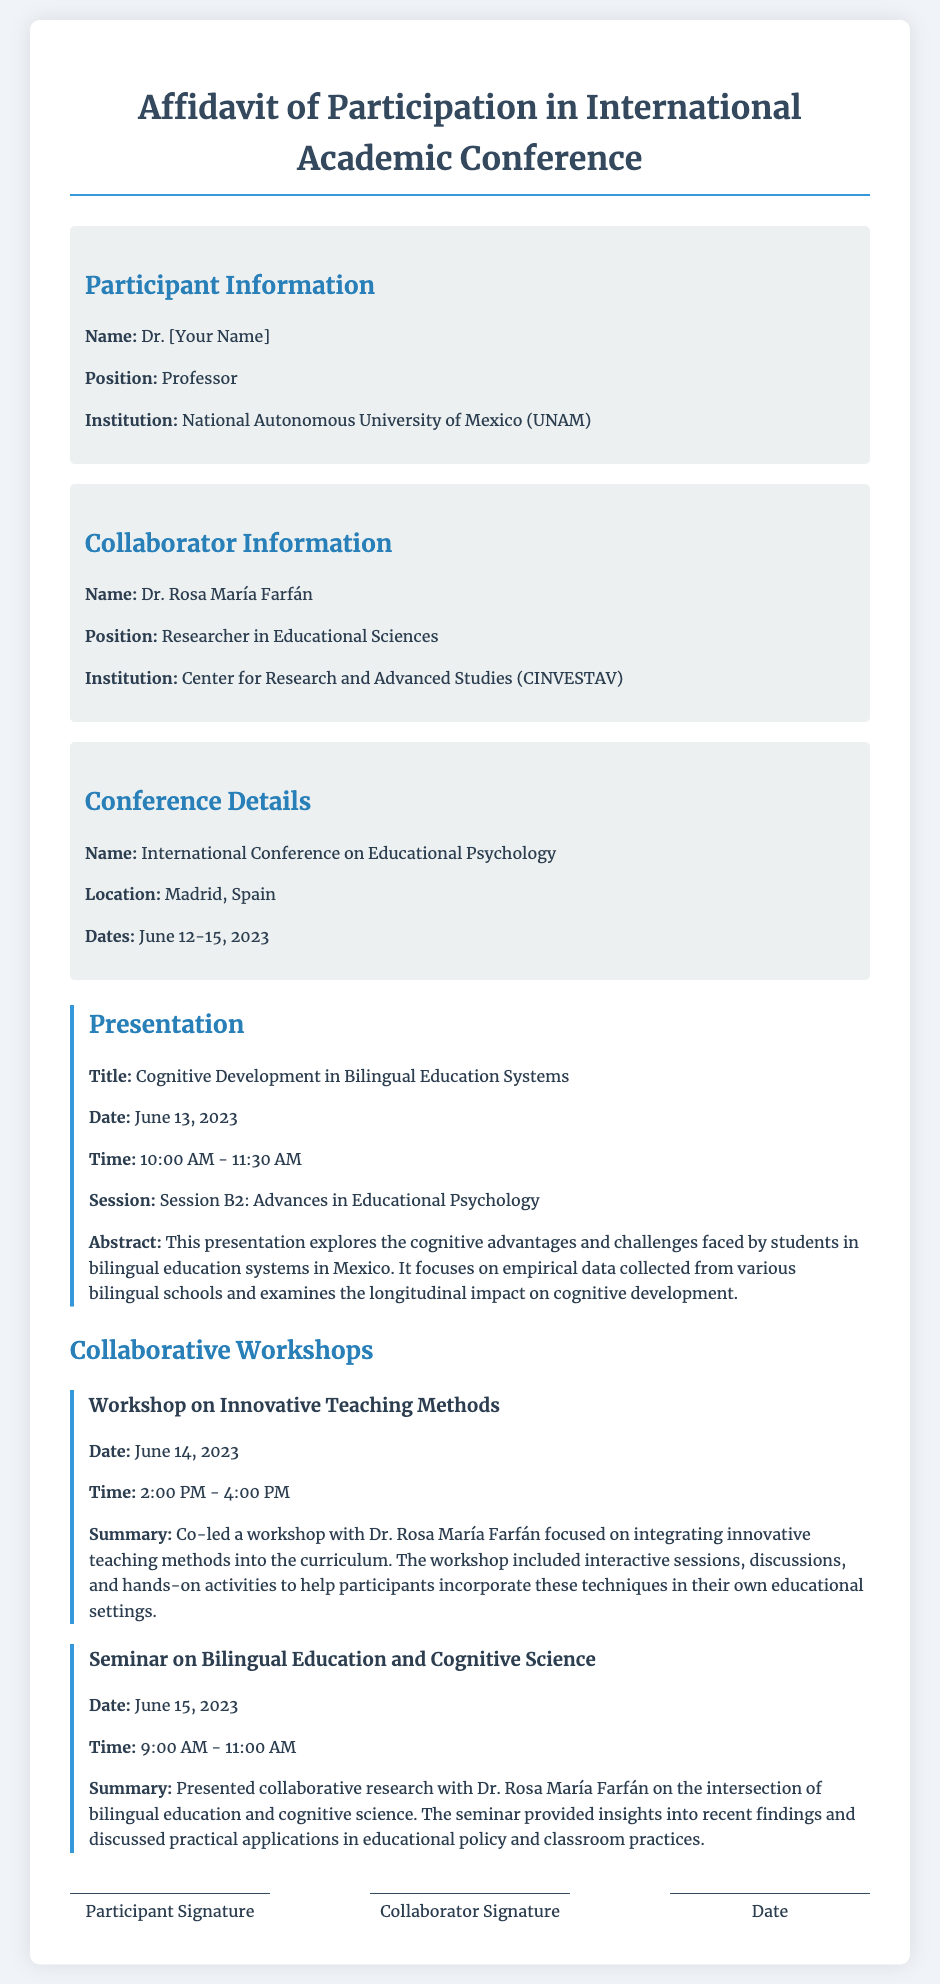What is the participant's name? The participant's name is found in the participant information section of the document.
Answer: Dr. [Your Name] What is the title of the presentation? The title of the presentation is specifically mentioned under the presentation section.
Answer: Cognitive Development in Bilingual Education Systems When did the conference take place? The dates of the conference are provided in the conference details section.
Answer: June 12-15, 2023 What time was the presentation scheduled? The time of the presentation is listed in the presentation details.
Answer: 10:00 AM - 11:30 AM Who co-led the workshop on innovative teaching methods? The collaborator involved in the workshop can be found in the workshop section of the document.
Answer: Dr. Rosa María Farfán What is the summary of the seminar on bilingual education? The seminar summary provides insights from the seminar section of the document.
Answer: Presented collaborative research with Dr. Rosa María Farfán on the intersection of bilingual education and cognitive science How many workshops were described in the document? The number of workshops can be counted based on the sections provided under collaborative workshops.
Answer: 2 